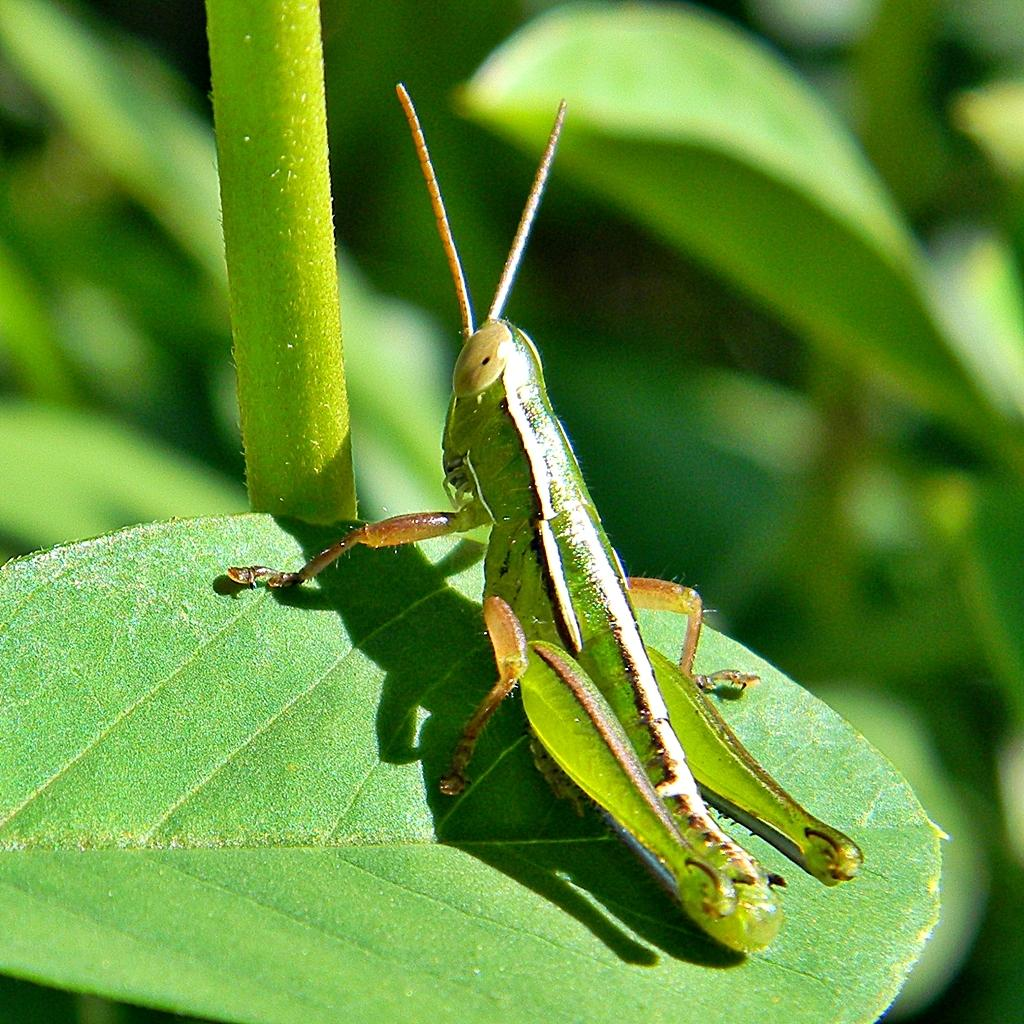What is the main subject of the image? There is an insect on a leaf in the image. Where is the insect located in relation to the image? The insect is at the bottom of the image. What can be seen in the background of the image? There is a stem and other leaves in the background of the image. What type of meal is the insect preparing on the leaf in the image? There is no indication in the image that the insect is preparing a meal or engaging in any activity other than being on the leaf. 